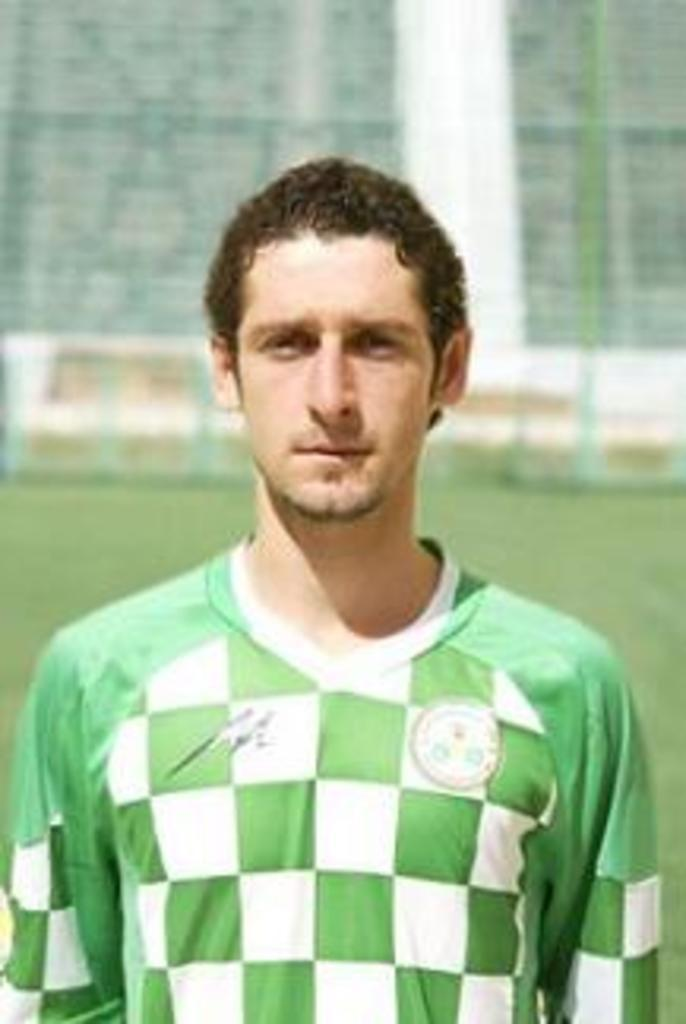Who is present in the image? There is a man in the image. What is the man wearing? The man is wearing a green and white color T-shirt. Can you describe the background of the image? The background of the image is blurred. How many birds can be seen flying in the quicksand in the image? There are no birds or quicksand present in the image. 